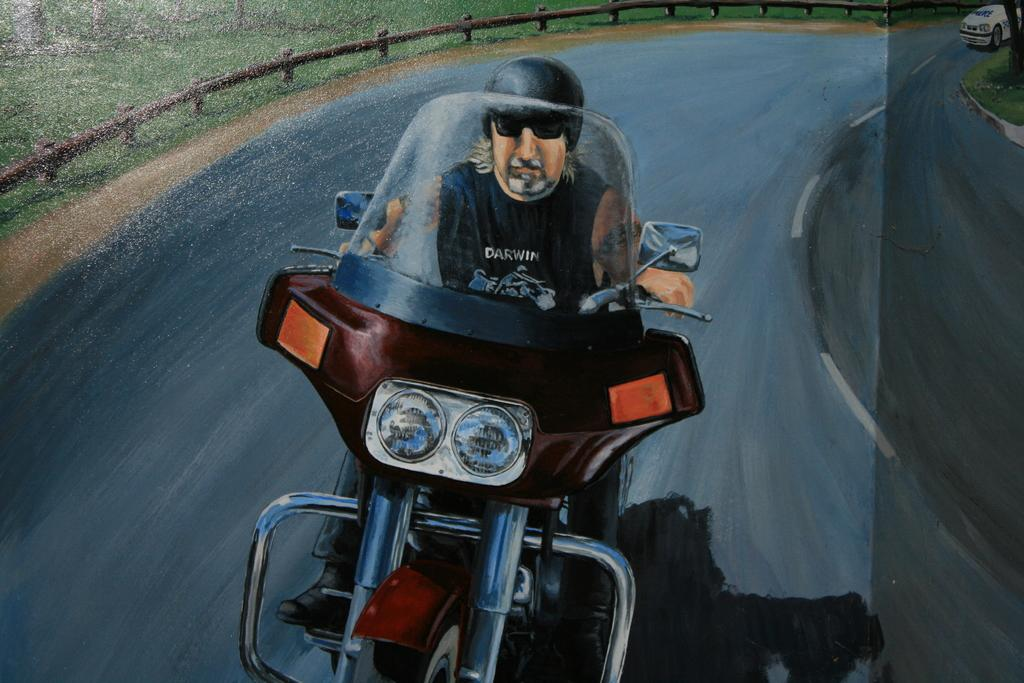What is the main subject of the image? There is a painting in the image. What activity is taking place in the image? A man is riding a bike on the road. What can be seen in the background of the image? There is a fence and grass on the ground in the background. Are there any vehicles visible in the image? Yes, there is a vehicle on the road in the background. What type of waste can be seen falling from the sky in the image? There is no waste falling from the sky in the image; it only features a painting, a man riding a bike, a fence, grass, and a vehicle on the road. 